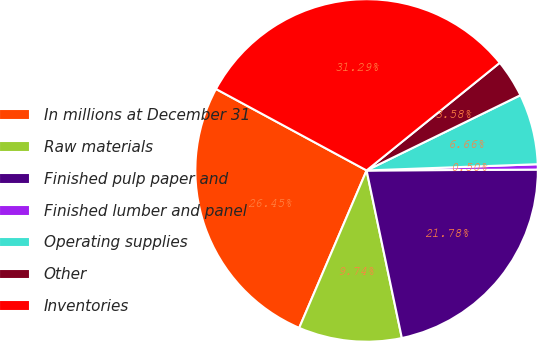Convert chart to OTSL. <chart><loc_0><loc_0><loc_500><loc_500><pie_chart><fcel>In millions at December 31<fcel>Raw materials<fcel>Finished pulp paper and<fcel>Finished lumber and panel<fcel>Operating supplies<fcel>Other<fcel>Inventories<nl><fcel>26.45%<fcel>9.74%<fcel>21.78%<fcel>0.5%<fcel>6.66%<fcel>3.58%<fcel>31.29%<nl></chart> 